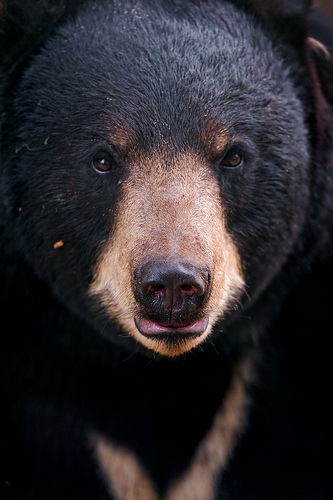If this bear were in a forest setting, what kind of environment would it be most suited to? This bear would likely thrive in a dense forest environment, which provides ample cover and a diverse food supply. The dark color of its fur would offer excellent camouflage among the trees and shadows, helping it to hunt unnoticed and avoid predators. The thick fur indicates adaptation to cooler climates, such as those found in northern forests or mountainous regions. 